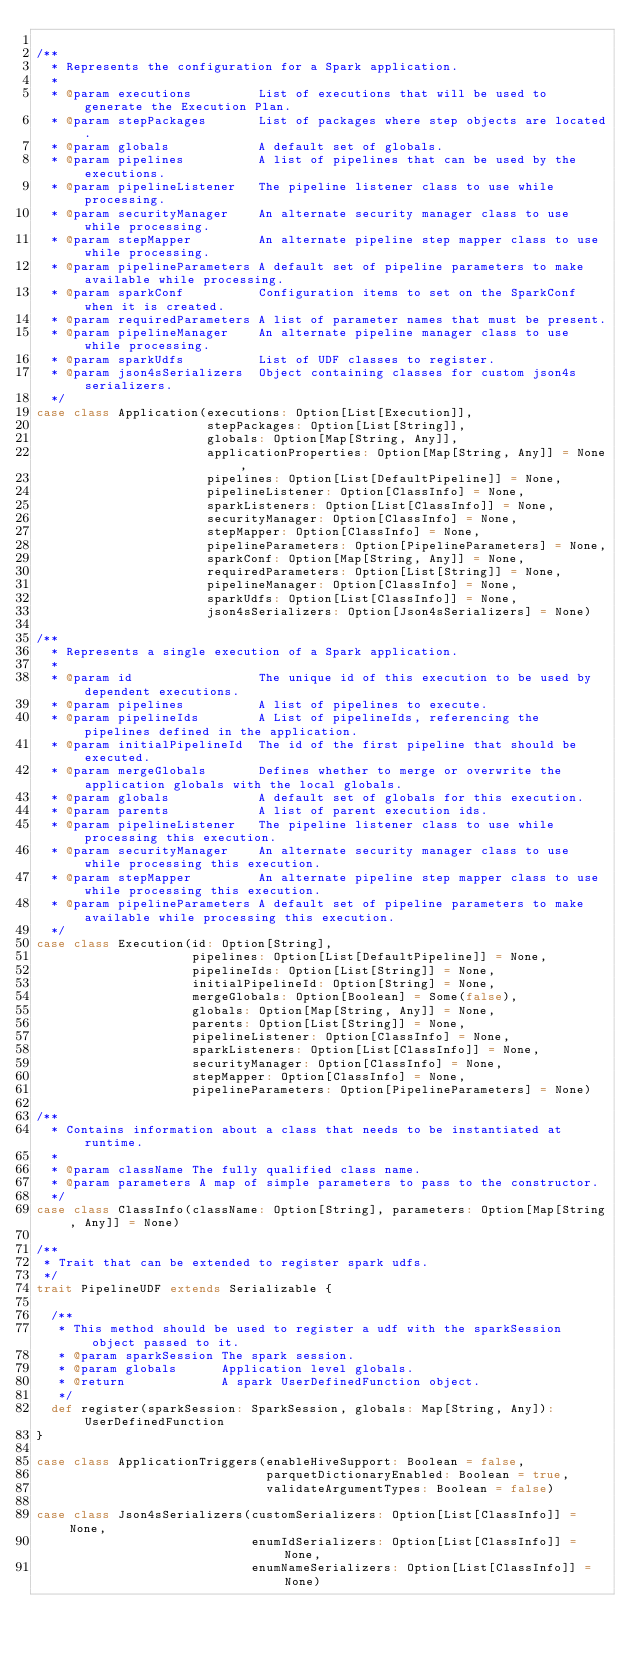Convert code to text. <code><loc_0><loc_0><loc_500><loc_500><_Scala_>
/**
  * Represents the configuration for a Spark application.
  *
  * @param executions         List of executions that will be used to generate the Execution Plan.
  * @param stepPackages       List of packages where step objects are located.
  * @param globals            A default set of globals.
  * @param pipelines          A list of pipelines that can be used by the executions.
  * @param pipelineListener   The pipeline listener class to use while processing.
  * @param securityManager    An alternate security manager class to use while processing.
  * @param stepMapper         An alternate pipeline step mapper class to use while processing.
  * @param pipelineParameters A default set of pipeline parameters to make available while processing.
  * @param sparkConf          Configuration items to set on the SparkConf when it is created.
  * @param requiredParameters A list of parameter names that must be present.
  * @param pipelineManager    An alternate pipeline manager class to use while processing.
  * @param sparkUdfs          List of UDF classes to register.
  * @param json4sSerializers  Object containing classes for custom json4s serializers.
  */
case class Application(executions: Option[List[Execution]],
                       stepPackages: Option[List[String]],
                       globals: Option[Map[String, Any]],
                       applicationProperties: Option[Map[String, Any]] = None,
                       pipelines: Option[List[DefaultPipeline]] = None,
                       pipelineListener: Option[ClassInfo] = None,
                       sparkListeners: Option[List[ClassInfo]] = None,
                       securityManager: Option[ClassInfo] = None,
                       stepMapper: Option[ClassInfo] = None,
                       pipelineParameters: Option[PipelineParameters] = None,
                       sparkConf: Option[Map[String, Any]] = None,
                       requiredParameters: Option[List[String]] = None,
                       pipelineManager: Option[ClassInfo] = None,
                       sparkUdfs: Option[List[ClassInfo]] = None,
                       json4sSerializers: Option[Json4sSerializers] = None)

/**
  * Represents a single execution of a Spark application.
  *
  * @param id                 The unique id of this execution to be used by dependent executions.
  * @param pipelines          A list of pipelines to execute.
  * @param pipelineIds        A List of pipelineIds, referencing the pipelines defined in the application.
  * @param initialPipelineId  The id of the first pipeline that should be executed.
  * @param mergeGlobals       Defines whether to merge or overwrite the application globals with the local globals.
  * @param globals            A default set of globals for this execution.
  * @param parents            A list of parent execution ids.
  * @param pipelineListener   The pipeline listener class to use while processing this execution.
  * @param securityManager    An alternate security manager class to use while processing this execution.
  * @param stepMapper         An alternate pipeline step mapper class to use while processing this execution.
  * @param pipelineParameters A default set of pipeline parameters to make available while processing this execution.
  */
case class Execution(id: Option[String],
                     pipelines: Option[List[DefaultPipeline]] = None,
                     pipelineIds: Option[List[String]] = None,
                     initialPipelineId: Option[String] = None,
                     mergeGlobals: Option[Boolean] = Some(false),
                     globals: Option[Map[String, Any]] = None,
                     parents: Option[List[String]] = None,
                     pipelineListener: Option[ClassInfo] = None,
                     sparkListeners: Option[List[ClassInfo]] = None,
                     securityManager: Option[ClassInfo] = None,
                     stepMapper: Option[ClassInfo] = None,
                     pipelineParameters: Option[PipelineParameters] = None)

/**
  * Contains information about a class that needs to be instantiated at runtime.
  *
  * @param className The fully qualified class name.
  * @param parameters A map of simple parameters to pass to the constructor.
  */
case class ClassInfo(className: Option[String], parameters: Option[Map[String, Any]] = None)

/**
 * Trait that can be extended to register spark udfs.
 */
trait PipelineUDF extends Serializable {

  /**
   * This method should be used to register a udf with the sparkSession object passed to it.
   * @param sparkSession The spark session.
   * @param globals      Application level globals.
   * @return             A spark UserDefinedFunction object.
   */
  def register(sparkSession: SparkSession, globals: Map[String, Any]): UserDefinedFunction
}

case class ApplicationTriggers(enableHiveSupport: Boolean = false,
                               parquetDictionaryEnabled: Boolean = true,
                               validateArgumentTypes: Boolean = false)

case class Json4sSerializers(customSerializers: Option[List[ClassInfo]] = None,
                             enumIdSerializers: Option[List[ClassInfo]] = None,
                             enumNameSerializers: Option[List[ClassInfo]] = None)
</code> 